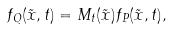<formula> <loc_0><loc_0><loc_500><loc_500>f _ { Q } ( \tilde { x } , t ) = M _ { t } ( \tilde { x } ) f _ { P } ( \tilde { x } , t ) ,</formula> 